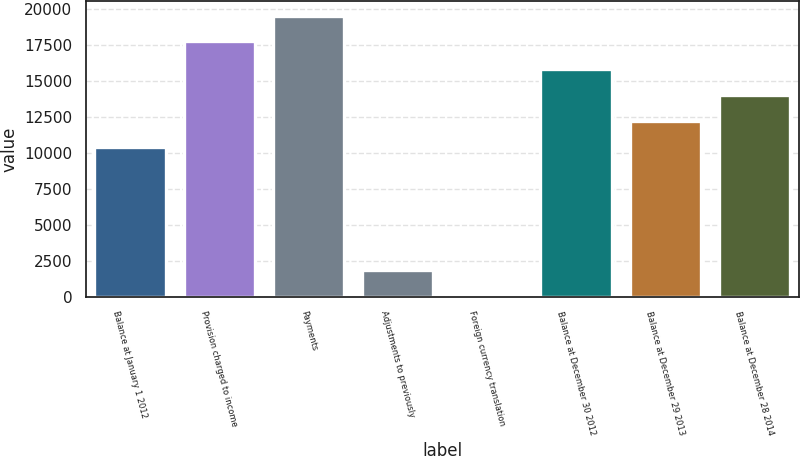<chart> <loc_0><loc_0><loc_500><loc_500><bar_chart><fcel>Balance at January 1 2012<fcel>Provision charged to income<fcel>Payments<fcel>Adjustments to previously<fcel>Foreign currency translation<fcel>Balance at December 30 2012<fcel>Balance at December 29 2013<fcel>Balance at December 28 2014<nl><fcel>10412<fcel>17750<fcel>19546<fcel>1858<fcel>62<fcel>15800<fcel>12208<fcel>14004<nl></chart> 